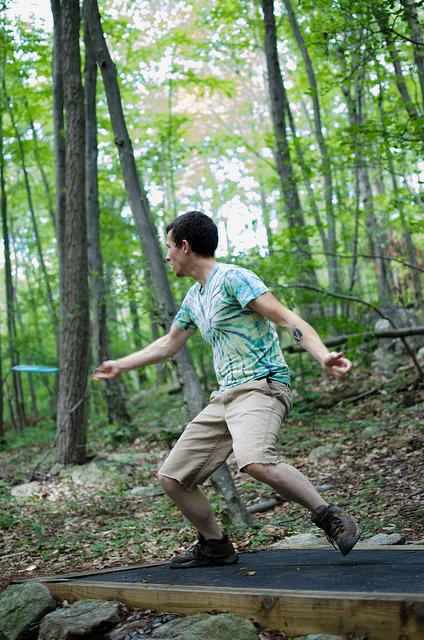Is this man trying to catch a green frisbee?
Give a very brief answer. No. What kind of shorts is this man wearing?
Keep it brief. Khaki. Are there green leaves on the trees?
Give a very brief answer. Yes. 